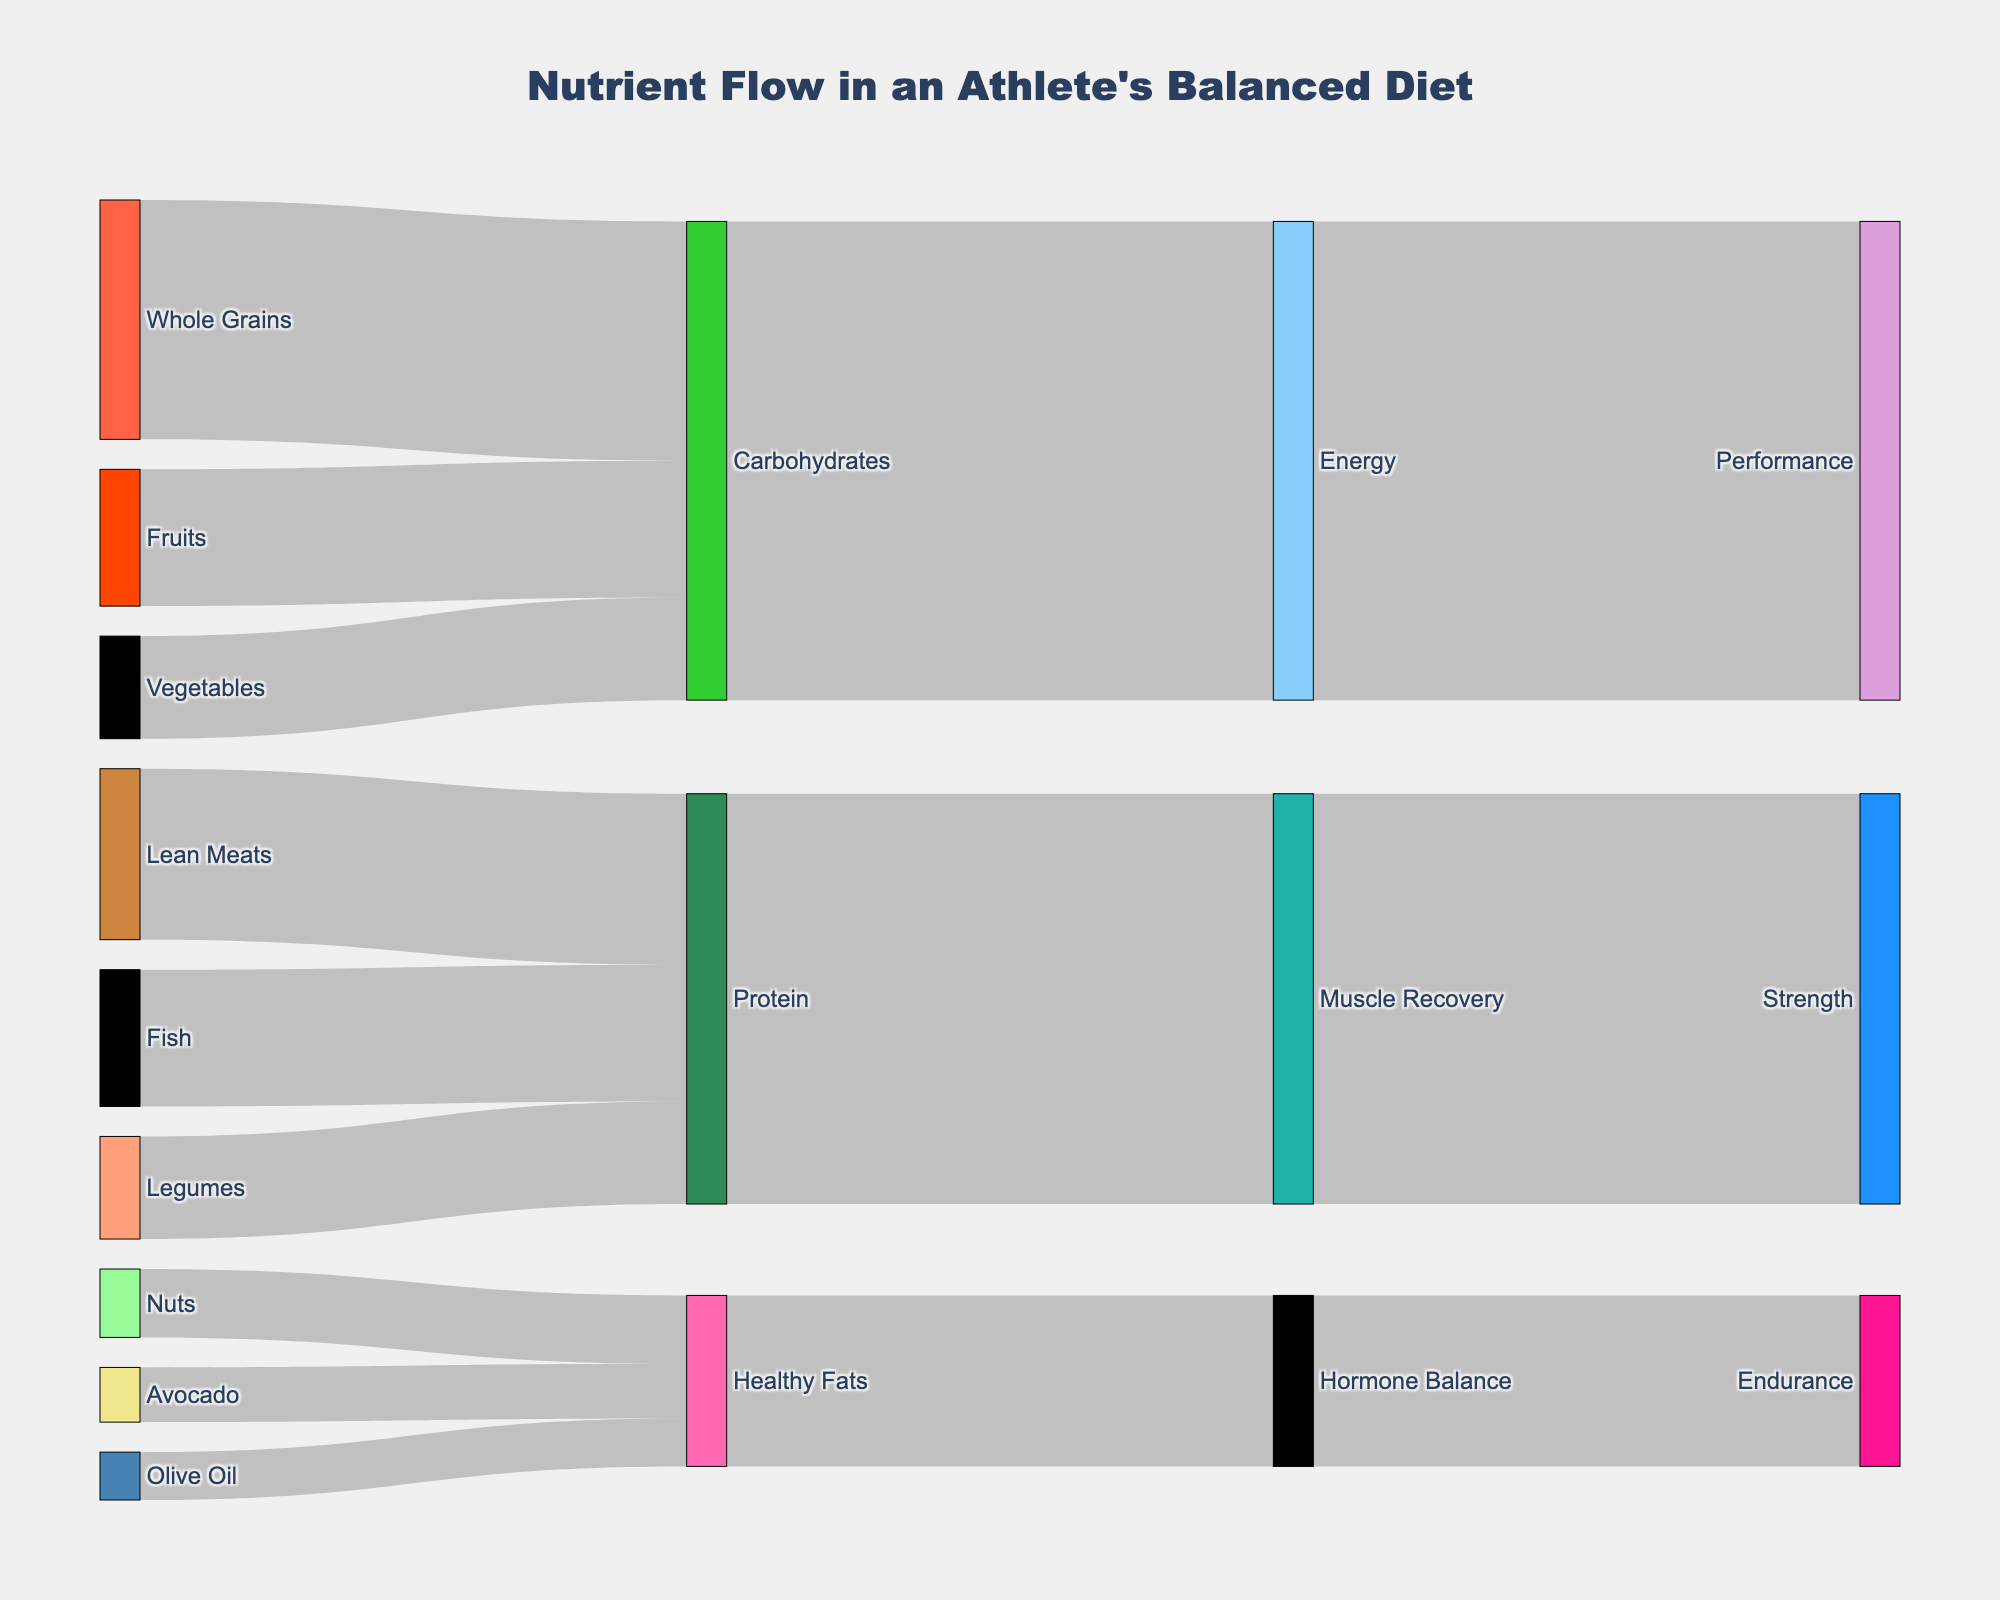What is the title of the Sankey diagram? The title is located at the top center of the diagram. It indicates the main topic of the visualization.
Answer: Nutrient Flow in an Athlete's Balanced Diet Which food sources contribute to protein? Identify all nodes labeled with food sources and follow the connections leading to the 'Protein' node.
Answer: Lean Meats, Fish, Legumes How much do whole grains contribute to carbohydrates? Find the connection from 'Whole Grains' to 'Carbohydrates' and check the value associated with it.
Answer: 35 What are the final target nodes in the diagram, and their respective values? The final target nodes are 'Performance', 'Strength', and 'Endurance'. Follow the paths from the sources to these nodes and sum up the values at the last transition.
Answer: Performance: 70, Strength: 60, Endurance: 25 Which food source has the smallest contribution and what is the nutrient it contributes to? Identify the food source with the smallest value among the connections to any nutrient node.
Answer: Olive Oil, Healthy Fats How many food sources contribute to healthy fats? Count all connections leading to the 'Healthy Fats' node from the initial food source nodes.
Answer: 3 What is the total contribution of vegetables to carbohydrates and how does it compare to fruits' contribution? Look at the values from 'Vegetables' and 'Fruits' to 'Carbohydrates', sum the values and compare them.
Answer: Vegetables: 15, Fruits: 20; Fruits contribute more by 5 Which macronutrient has the highest combined contribution from all its sources? Sum the values of all sources leading to each macronutrient node (Carbohydrates, Protein, Healthy Fats) and compare the sums.
Answer: Carbohydrates: 70, Protein: 60, Healthy Fats: 25; Carbohydrates are the highest What is the relationship between 'Energy' and 'Performance' in terms of value? Follow the connection from 'Energy' to 'Performance' and check the value associated with it.
Answer: 70 